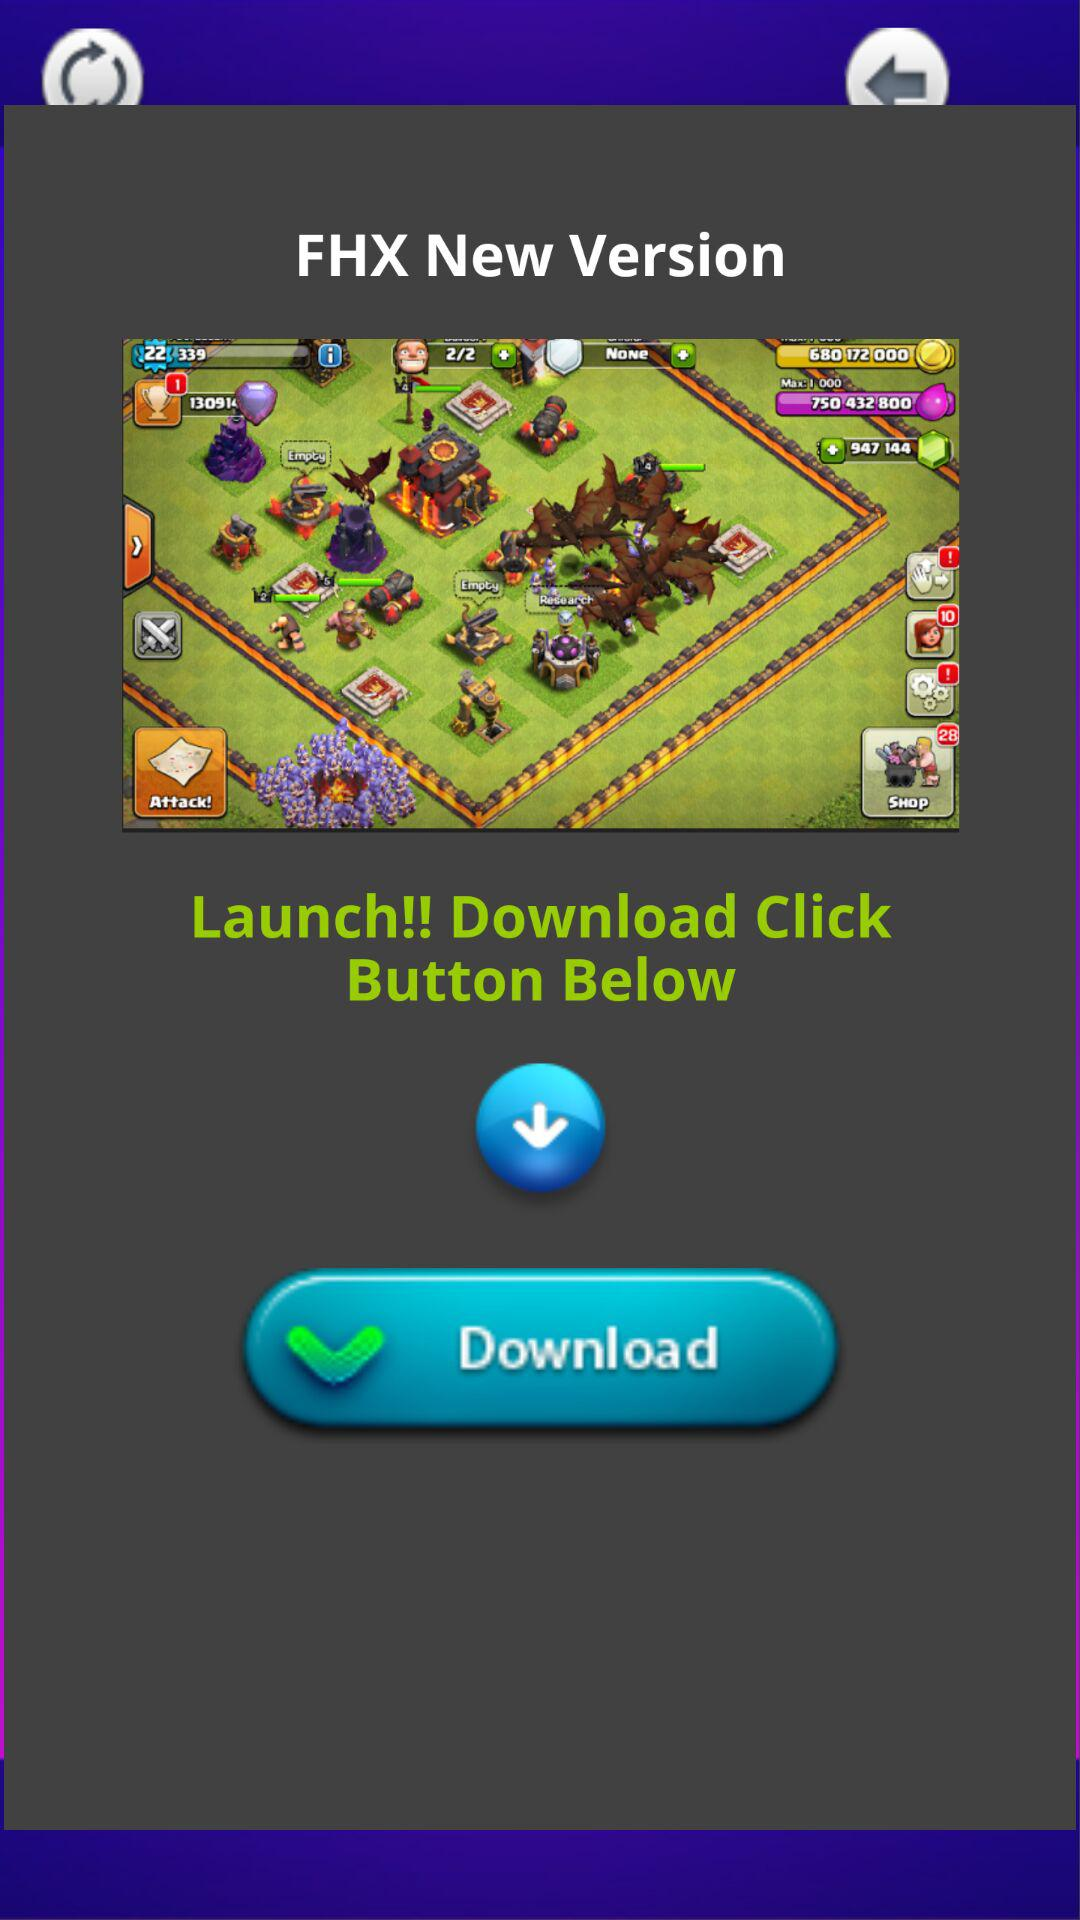What is the name of the application? The name of the application is "FHX". 